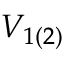Convert formula to latex. <formula><loc_0><loc_0><loc_500><loc_500>V _ { 1 ( 2 ) }</formula> 